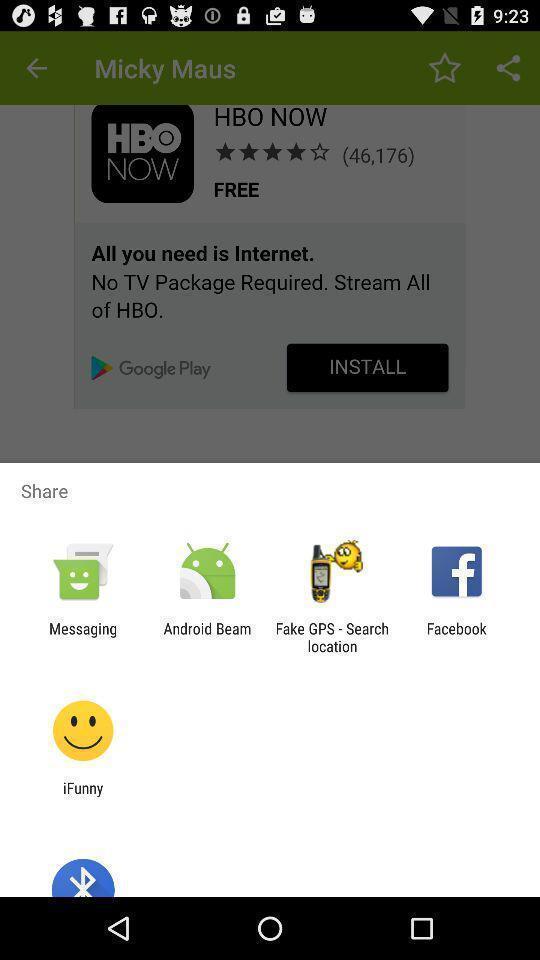What can you discern from this picture? Pop-up of icons to share for the online marketing app. 